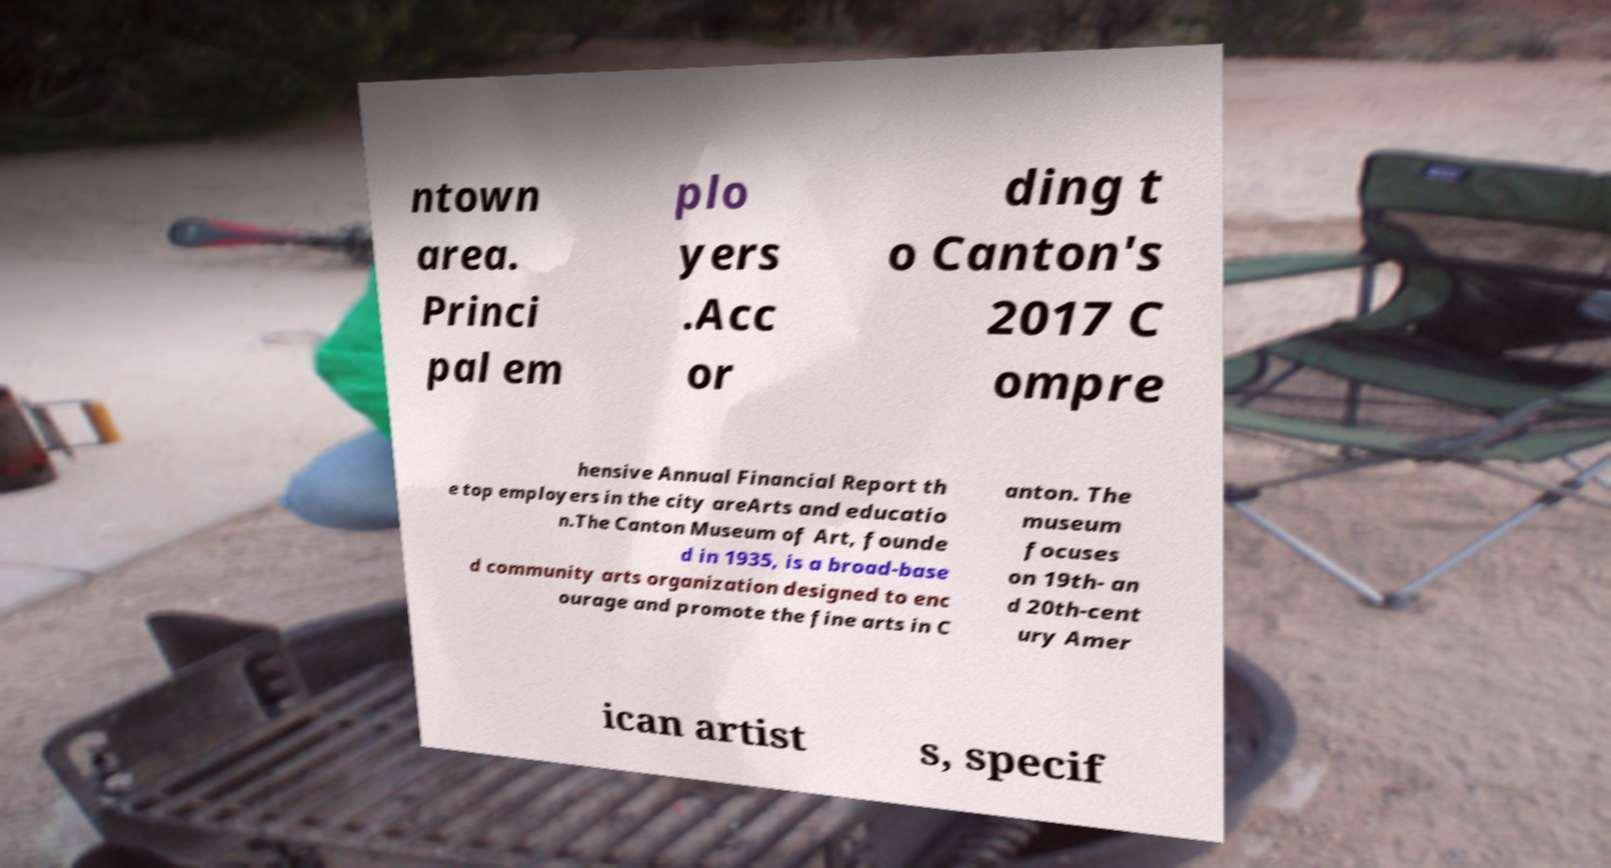Please identify and transcribe the text found in this image. ntown area. Princi pal em plo yers .Acc or ding t o Canton's 2017 C ompre hensive Annual Financial Report th e top employers in the city areArts and educatio n.The Canton Museum of Art, founde d in 1935, is a broad-base d community arts organization designed to enc ourage and promote the fine arts in C anton. The museum focuses on 19th- an d 20th-cent ury Amer ican artist s, specif 